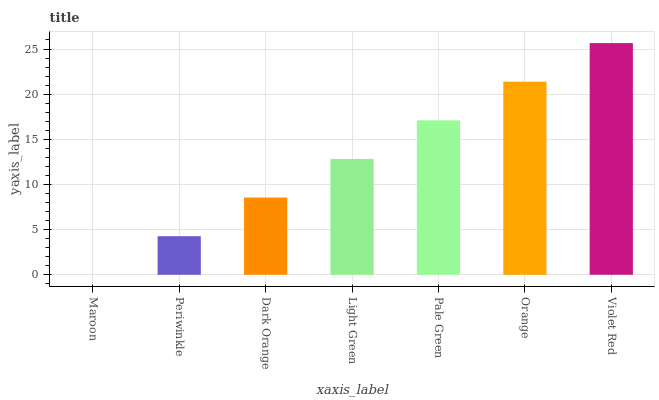Is Maroon the minimum?
Answer yes or no. Yes. Is Violet Red the maximum?
Answer yes or no. Yes. Is Periwinkle the minimum?
Answer yes or no. No. Is Periwinkle the maximum?
Answer yes or no. No. Is Periwinkle greater than Maroon?
Answer yes or no. Yes. Is Maroon less than Periwinkle?
Answer yes or no. Yes. Is Maroon greater than Periwinkle?
Answer yes or no. No. Is Periwinkle less than Maroon?
Answer yes or no. No. Is Light Green the high median?
Answer yes or no. Yes. Is Light Green the low median?
Answer yes or no. Yes. Is Dark Orange the high median?
Answer yes or no. No. Is Periwinkle the low median?
Answer yes or no. No. 